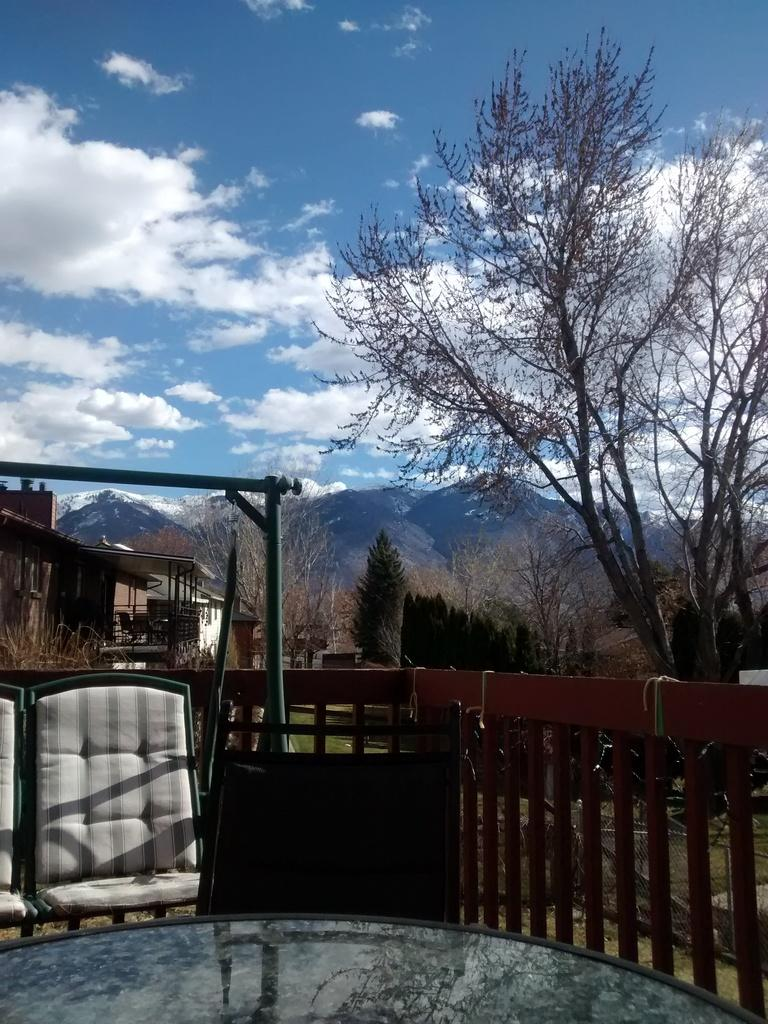What type of structures can be seen in the image? There are buildings in the image. What natural elements are present in the image? There are trees and a hill in the image. What is the condition of the sky in the image? The sky is blue and cloudy in the image. What type of furniture is visible in the image? There is a glass table and a chair swing cradle in the image. What type of barrier is present in the image? There is a wooden fence in the image. Can you see friends playing with a crown in the image? There are no friends or crowns present in the image. 